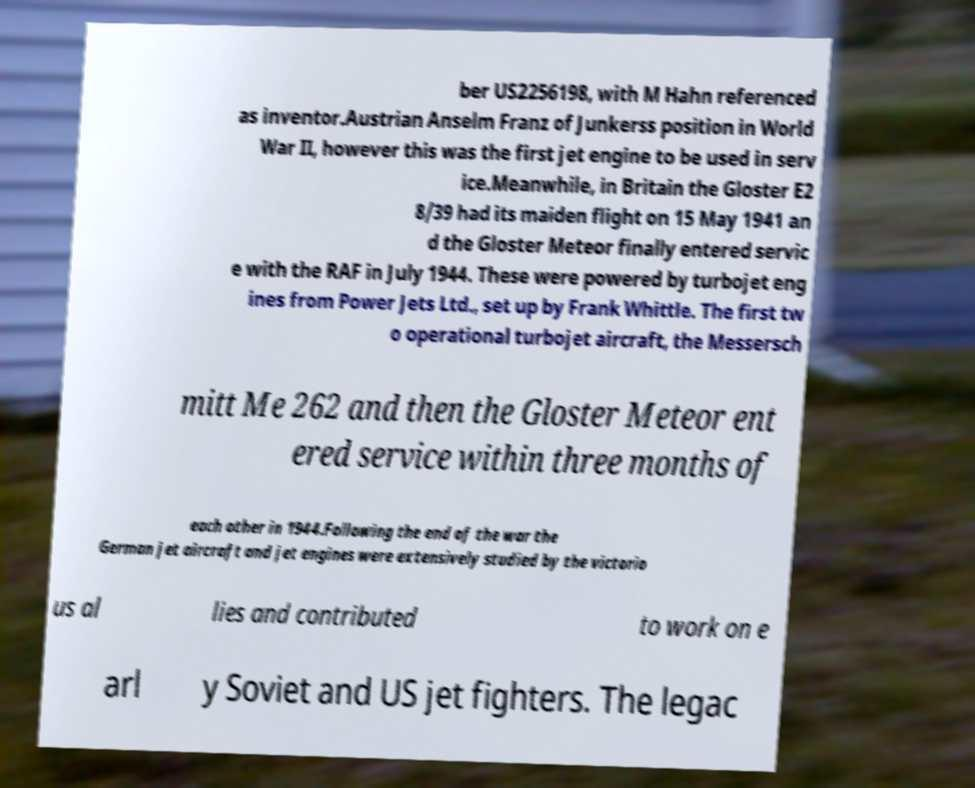Could you assist in decoding the text presented in this image and type it out clearly? ber US2256198, with M Hahn referenced as inventor.Austrian Anselm Franz of Junkerss position in World War II, however this was the first jet engine to be used in serv ice.Meanwhile, in Britain the Gloster E2 8/39 had its maiden flight on 15 May 1941 an d the Gloster Meteor finally entered servic e with the RAF in July 1944. These were powered by turbojet eng ines from Power Jets Ltd., set up by Frank Whittle. The first tw o operational turbojet aircraft, the Messersch mitt Me 262 and then the Gloster Meteor ent ered service within three months of each other in 1944.Following the end of the war the German jet aircraft and jet engines were extensively studied by the victorio us al lies and contributed to work on e arl y Soviet and US jet fighters. The legac 